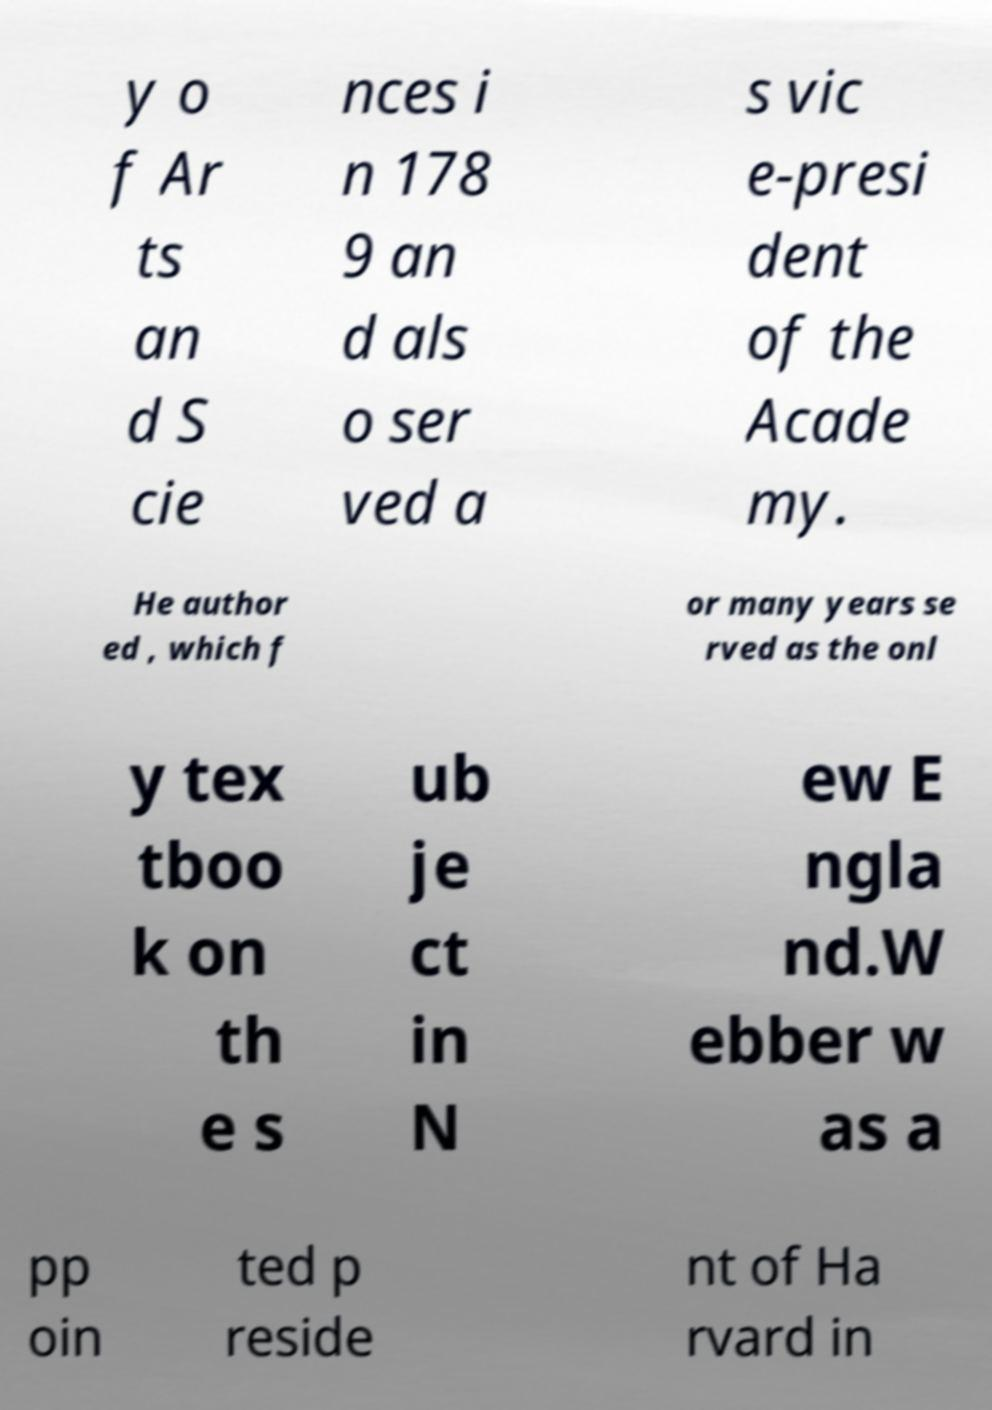For documentation purposes, I need the text within this image transcribed. Could you provide that? y o f Ar ts an d S cie nces i n 178 9 an d als o ser ved a s vic e-presi dent of the Acade my. He author ed , which f or many years se rved as the onl y tex tboo k on th e s ub je ct in N ew E ngla nd.W ebber w as a pp oin ted p reside nt of Ha rvard in 